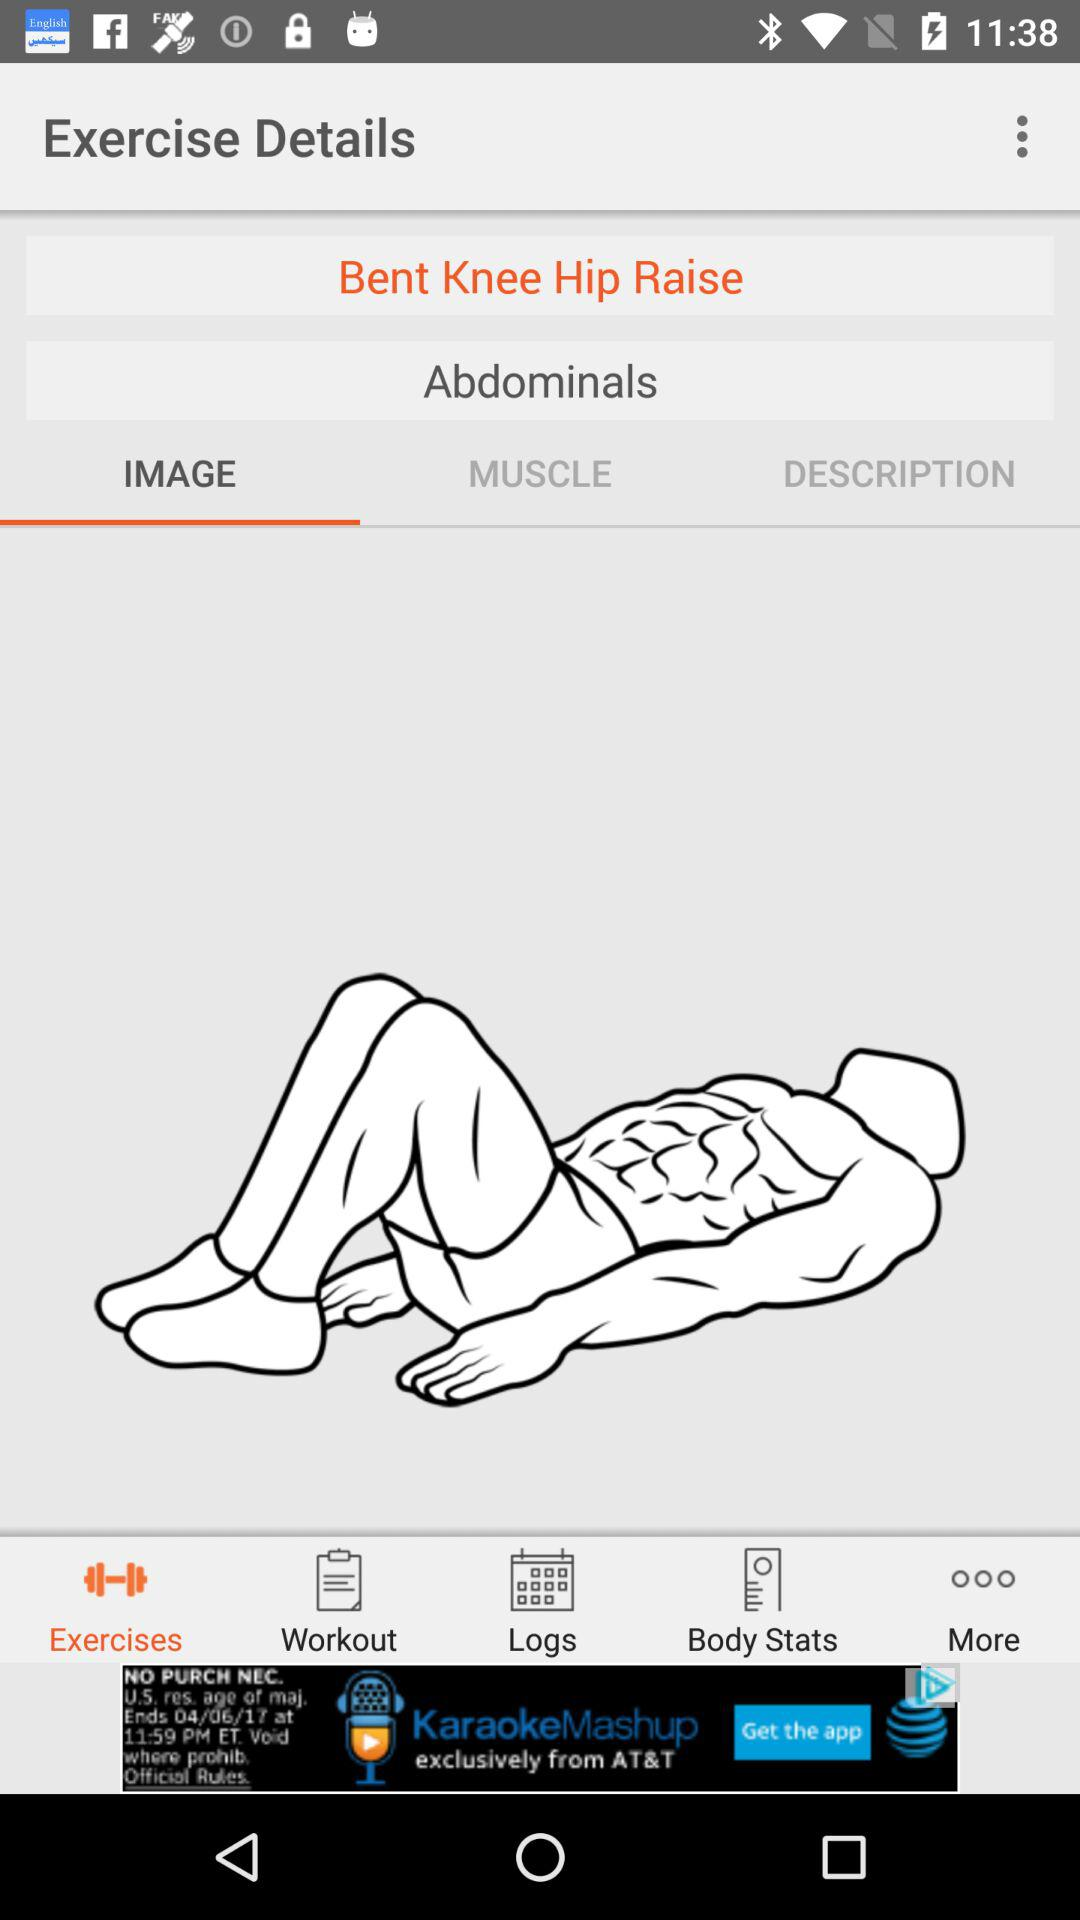What is the name of the exercise? The name of the exercise is "Bent Knee Hip Raise". 